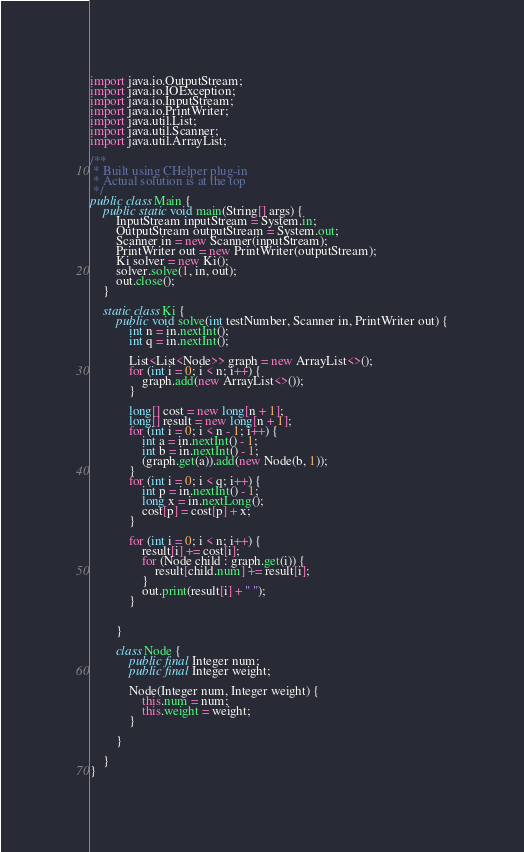Convert code to text. <code><loc_0><loc_0><loc_500><loc_500><_Java_>import java.io.OutputStream;
import java.io.IOException;
import java.io.InputStream;
import java.io.PrintWriter;
import java.util.List;
import java.util.Scanner;
import java.util.ArrayList;

/**
 * Built using CHelper plug-in
 * Actual solution is at the top
 */
public class Main {
    public static void main(String[] args) {
        InputStream inputStream = System.in;
        OutputStream outputStream = System.out;
        Scanner in = new Scanner(inputStream);
        PrintWriter out = new PrintWriter(outputStream);
        Ki solver = new Ki();
        solver.solve(1, in, out);
        out.close();
    }

    static class Ki {
        public void solve(int testNumber, Scanner in, PrintWriter out) {
            int n = in.nextInt();
            int q = in.nextInt();

            List<List<Node>> graph = new ArrayList<>();
            for (int i = 0; i < n; i++) {
                graph.add(new ArrayList<>());
            }

            long[] cost = new long[n + 1];
            long[] result = new long[n + 1];
            for (int i = 0; i < n - 1; i++) {
                int a = in.nextInt() - 1;
                int b = in.nextInt() - 1;
                (graph.get(a)).add(new Node(b, 1));
            }
            for (int i = 0; i < q; i++) {
                int p = in.nextInt() - 1;
                long x = in.nextLong();
                cost[p] = cost[p] + x;
            }

            for (int i = 0; i < n; i++) {
                result[i] += cost[i];
                for (Node child : graph.get(i)) {
                    result[child.num] += result[i];
                }
                out.print(result[i] + " ");
            }


        }

        class Node {
            public final Integer num;
            public final Integer weight;

            Node(Integer num, Integer weight) {
                this.num = num;
                this.weight = weight;
            }

        }

    }
}

</code> 